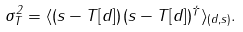Convert formula to latex. <formula><loc_0><loc_0><loc_500><loc_500>\sigma _ { T } ^ { 2 } = \langle ( s - T [ d ] ) \, ( s - T [ d ] ) ^ { \dagger } \rangle _ { ( d , s ) } .</formula> 